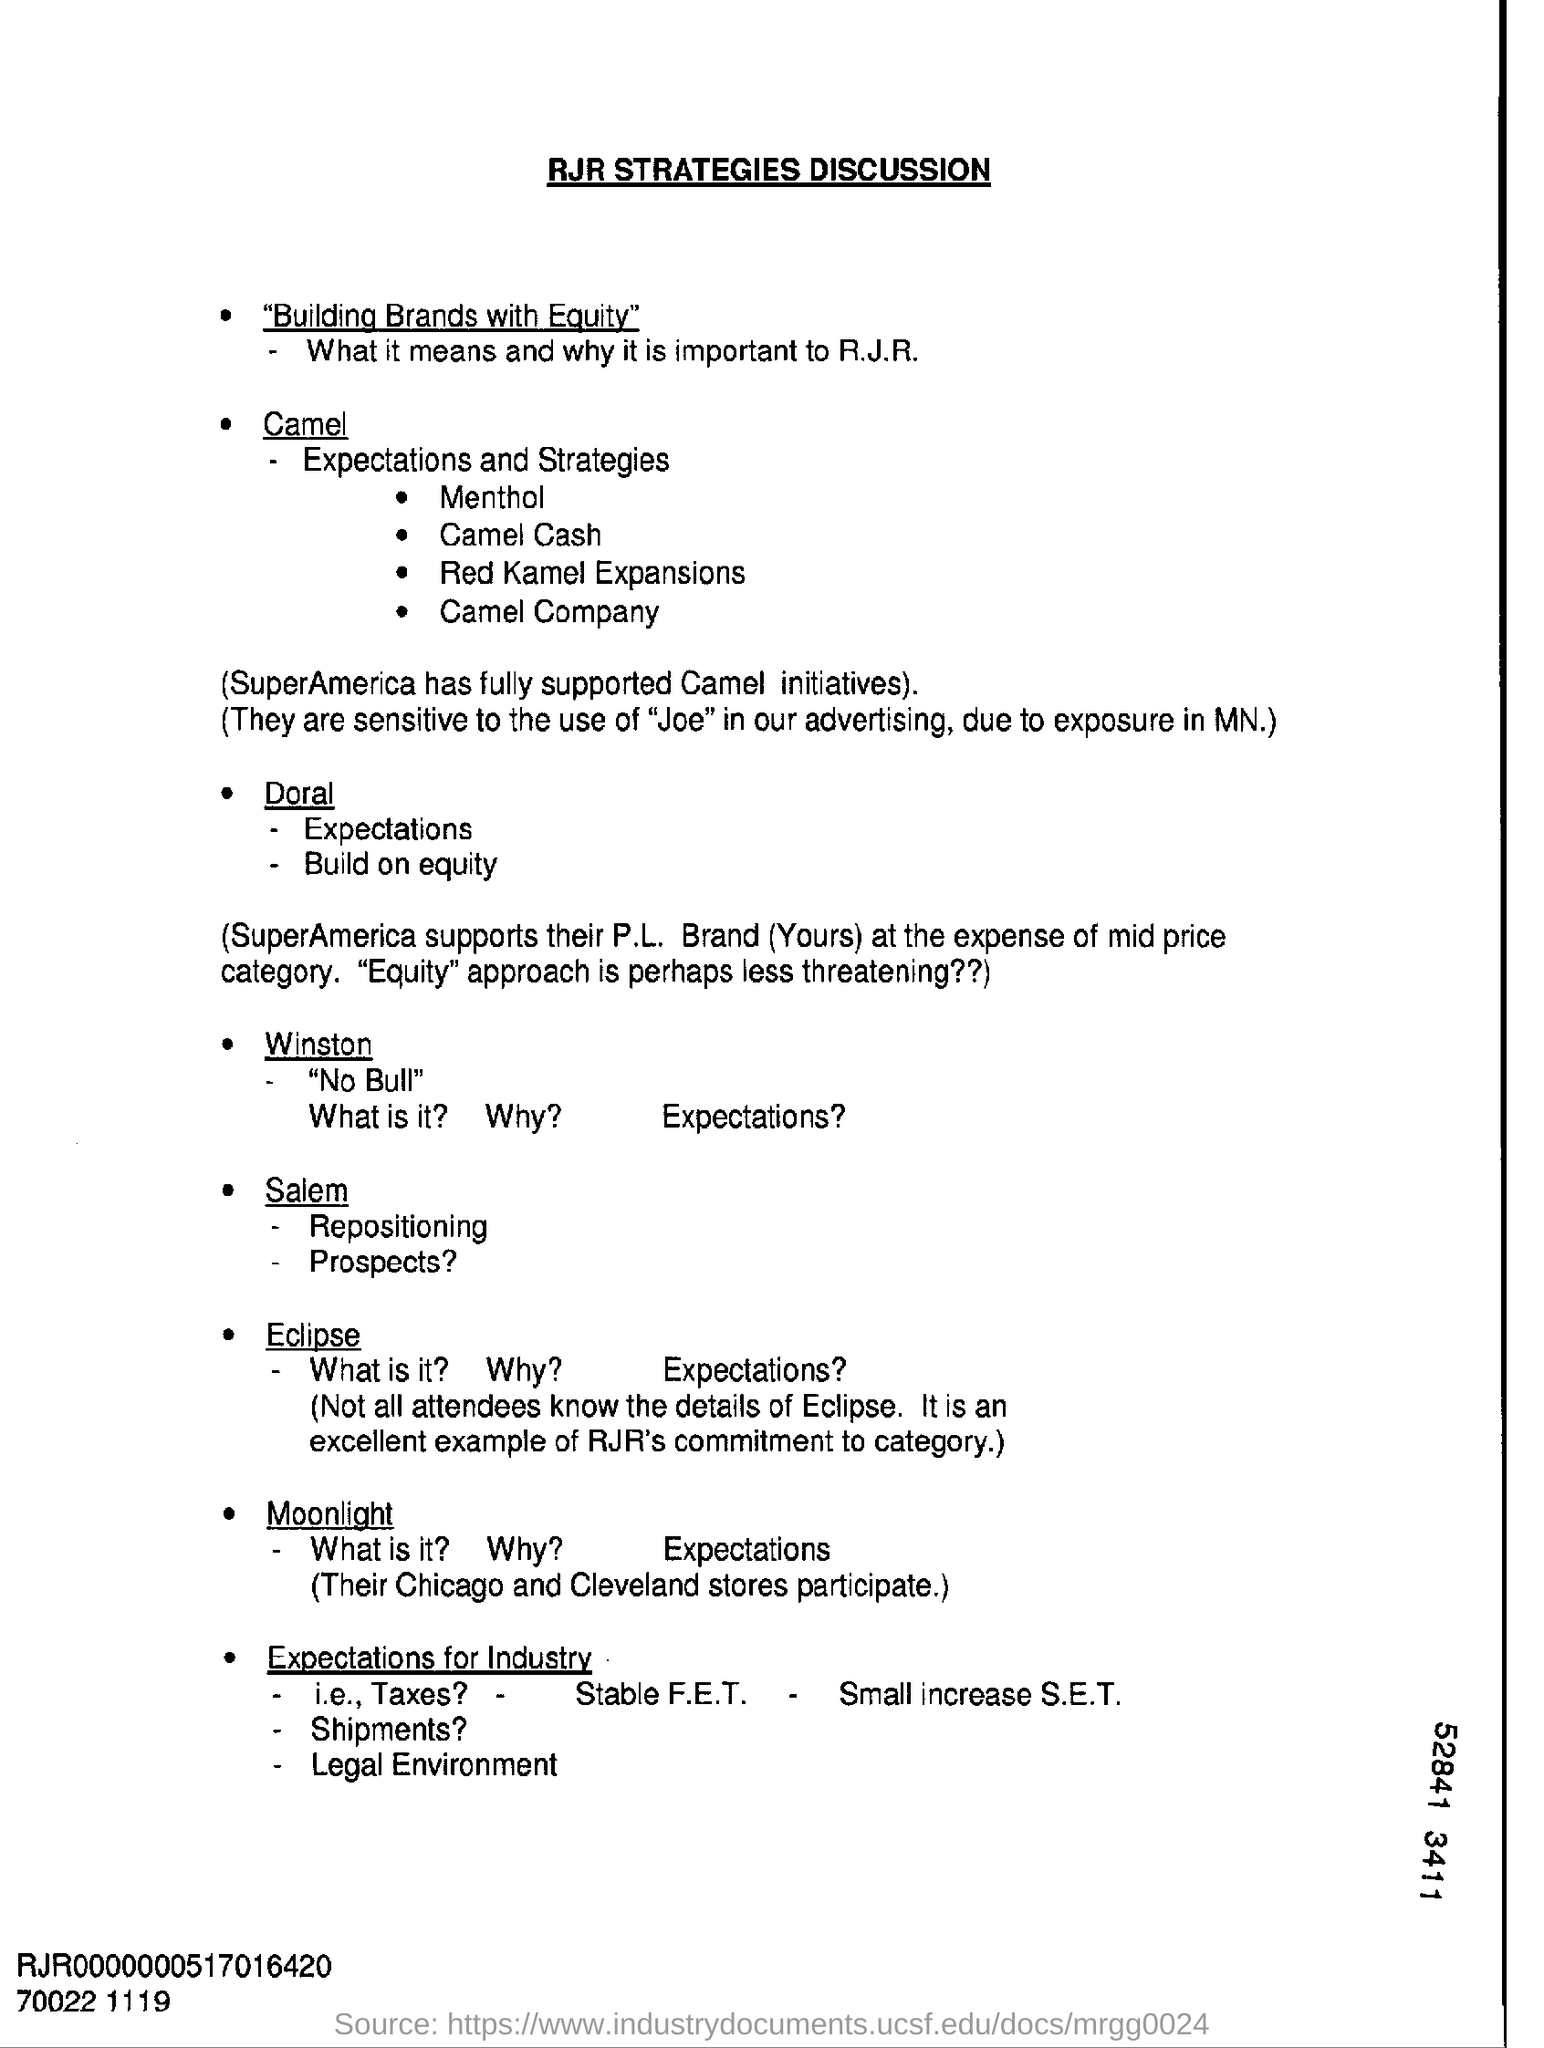What is the heading at top of the page ?
Your response must be concise. RJR strategies discussion. 